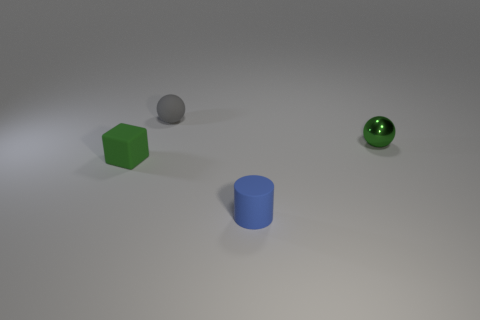Subtract all cylinders. How many objects are left? 3 Add 4 green shiny balls. How many green shiny balls exist? 5 Add 4 tiny balls. How many objects exist? 8 Subtract 0 yellow cubes. How many objects are left? 4 Subtract 1 balls. How many balls are left? 1 Subtract all yellow balls. Subtract all gray cylinders. How many balls are left? 2 Subtract all red spheres. How many red cubes are left? 0 Subtract all purple metallic things. Subtract all cylinders. How many objects are left? 3 Add 3 tiny green metal spheres. How many tiny green metal spheres are left? 4 